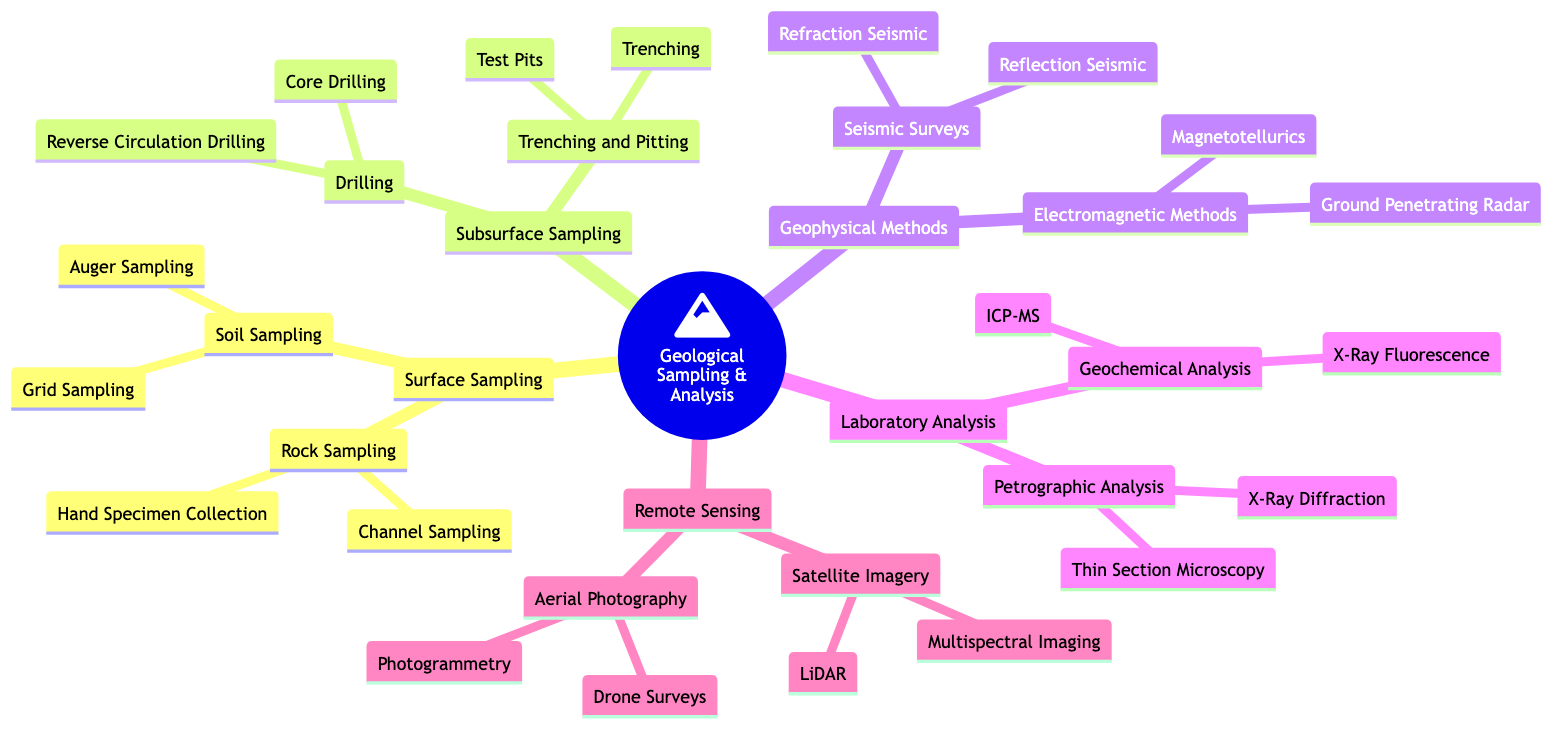What is the main category of the Mind Map? The root node clearly states that the main category discussed in this diagram is "Geological Sampling & Analysis."
Answer: Geological Sampling & Analysis How many primary categories are there under "Techniques for Geological Sampling and Analysis"? There are five main categories branching out from the root: Surface Sampling, Subsurface Sampling, Geophysical Methods, Laboratory Analysis, and Remote Sensing.
Answer: 5 Which method is included in "Surface Sampling"? The diagram indicates two types of sampling in this category: Rock Sampling and Soil Sampling.
Answer: Rock Sampling, Soil Sampling What is the method used for collecting soil samples at regular intervals? The "Grid Sampling" method is identified under the "Soil Sampling" subcategory for collecting samples systematically.
Answer: Grid Sampling How does "Core Drilling" differ from "Reverse Circulation Drilling"? Core Drilling involves extracting a cylindrical core for analysis, while Reverse Circulation Drilling collects rock fragments or chips from varying depths.
Answer: Core Drilling, Reverse Circulation Drilling What type of survey uses the reflection of seismic waves for mapping? The "Reflection Seismic" method is mentioned under the "Seismic Surveys" category within Geophysical Methods for this purpose.
Answer: Reflection Seismic Which laboratory analysis technique involves examining thin sections of rocks under a microscope? "Thin Section Microscopy" is explicitly stated as a technique for examining thin sections in the "Petrographic Analysis" subcategory.
Answer: Thin Section Microscopy What technology is used in "Remote Sensing" for detailed topographic maps? "LiDAR," mentioned under "Satellite Imagery," is the technology used for creating detailed topographic maps.
Answer: LiDAR Which aerial photography method captures high-resolution images using UAVs? The "Drone Surveys" method is specifically listed under the "Aerial Photography" category for capturing these images.
Answer: Drone Surveys 